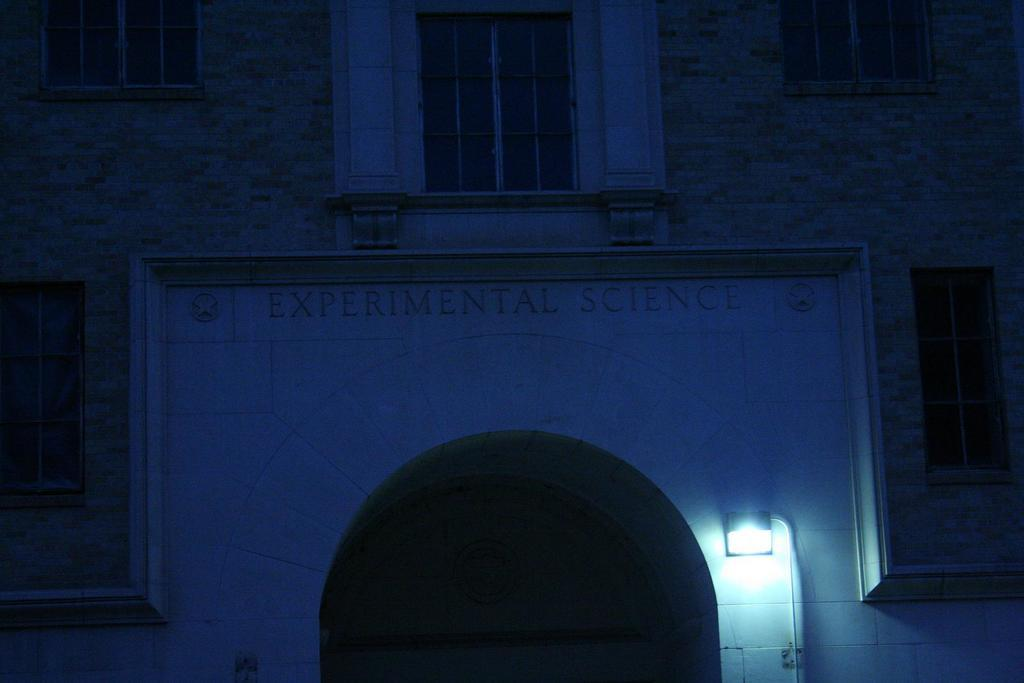What type of structure is present in the image? There is a building in the image. What architectural features can be seen on the building? The building has windows and a door. Can you describe the lighting conditions in the image? There is light visible in the image. What other object can be seen in the image? There is a pole in the image. What is the background of the image made of? There is a wall in the image. Is there any text visible in the image? Yes, there is some text visible in the image. Where is the park located in the image? There is no park present in the image. Can you tell me how many balloons are floating near the building in the image? There are no balloons present in the image. 